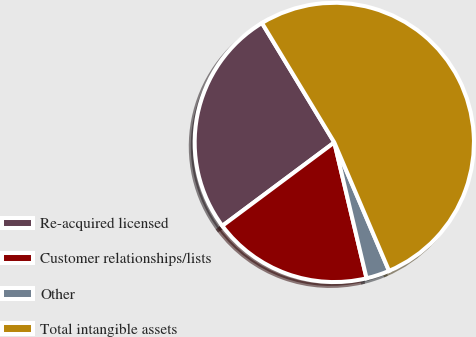Convert chart to OTSL. <chart><loc_0><loc_0><loc_500><loc_500><pie_chart><fcel>Re-acquired licensed<fcel>Customer relationships/lists<fcel>Other<fcel>Total intangible assets<nl><fcel>26.52%<fcel>18.52%<fcel>2.7%<fcel>52.25%<nl></chart> 